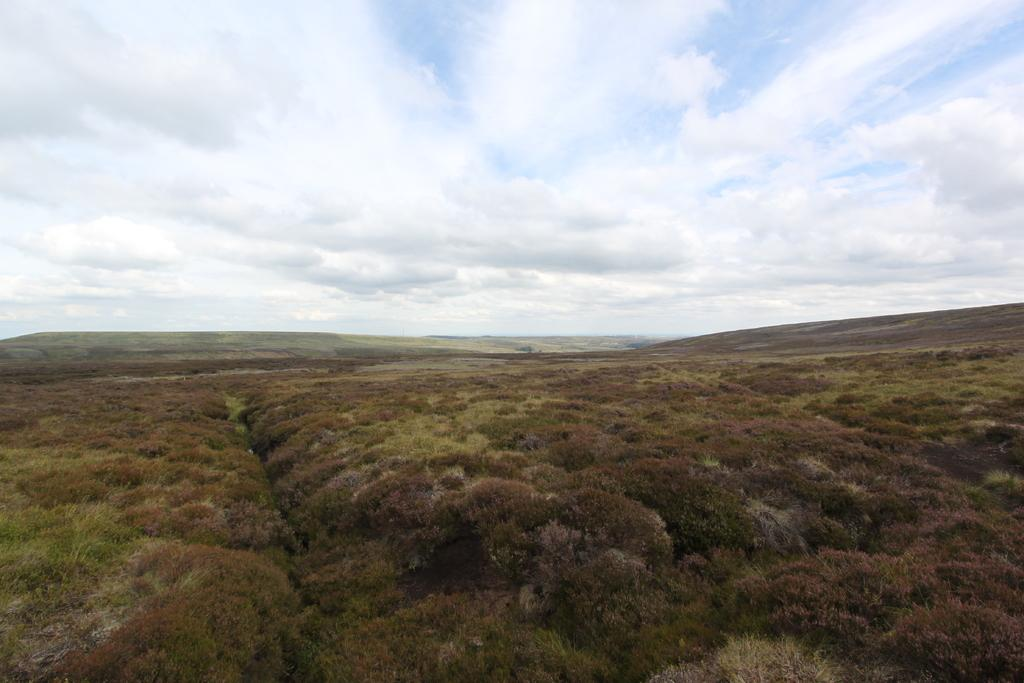What is the location of the image in relation to the landscape? The image is taken over a hill. What type of vegetation is present in the foreground of the image? There are shrubs in the foreground of the picture. What can be seen in the center of the image? There are hills in the center of the picture. What is visible at the top of the image? The sky is visible at the top of the image. What is the weather like in the image? The sky is cloudy, which suggests a partly cloudy or overcast day. What type of rat can be seen running across the van in the image? There is no rat or van present in the image; it features a landscape with hills and shrubs. Is there a church visible in the image? There is no church present in the image. 